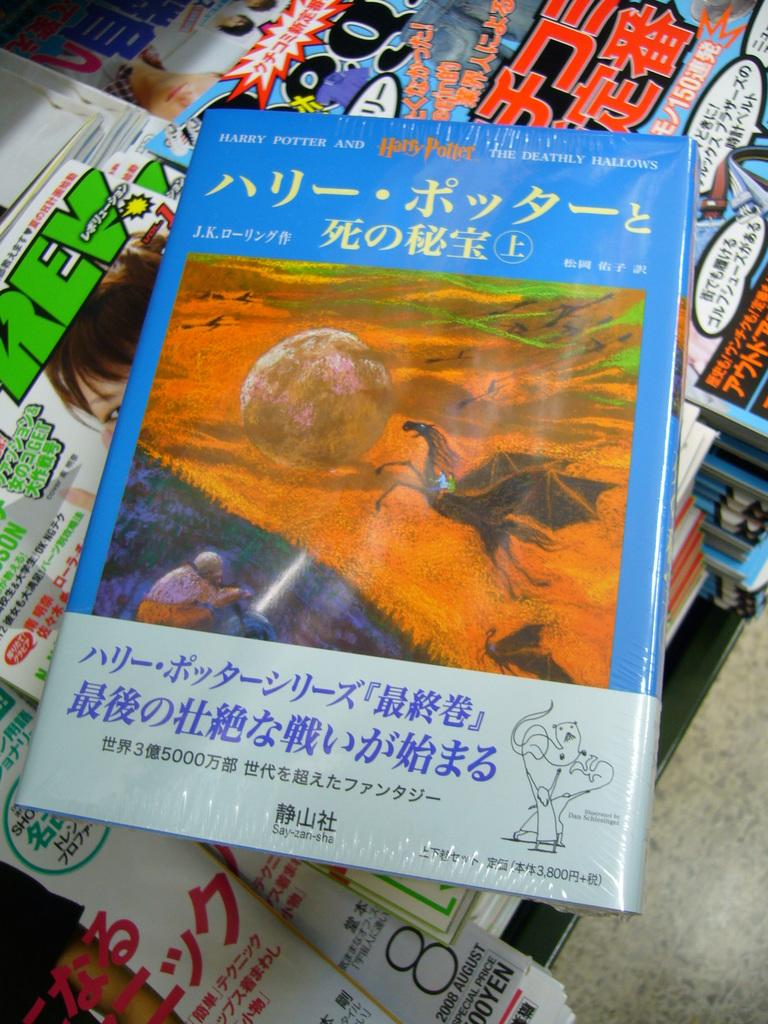<image>
Render a clear and concise summary of the photo. A Harry Potter book features a picture of a big boulder on the cover. 